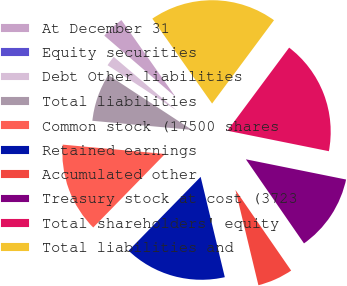Convert chart to OTSL. <chart><loc_0><loc_0><loc_500><loc_500><pie_chart><fcel>At December 31<fcel>Equity securities<fcel>Debt Other liabilities<fcel>Total liabilities<fcel>Common stock (17500 shares<fcel>Retained earnings<fcel>Accumulated other<fcel>Treasury stock at cost (3723<fcel>Total shareholders' equity<fcel>Total liabilities and<nl><fcel>3.93%<fcel>0.07%<fcel>2.0%<fcel>7.79%<fcel>14.14%<fcel>16.07%<fcel>5.86%<fcel>12.21%<fcel>18.0%<fcel>19.93%<nl></chart> 